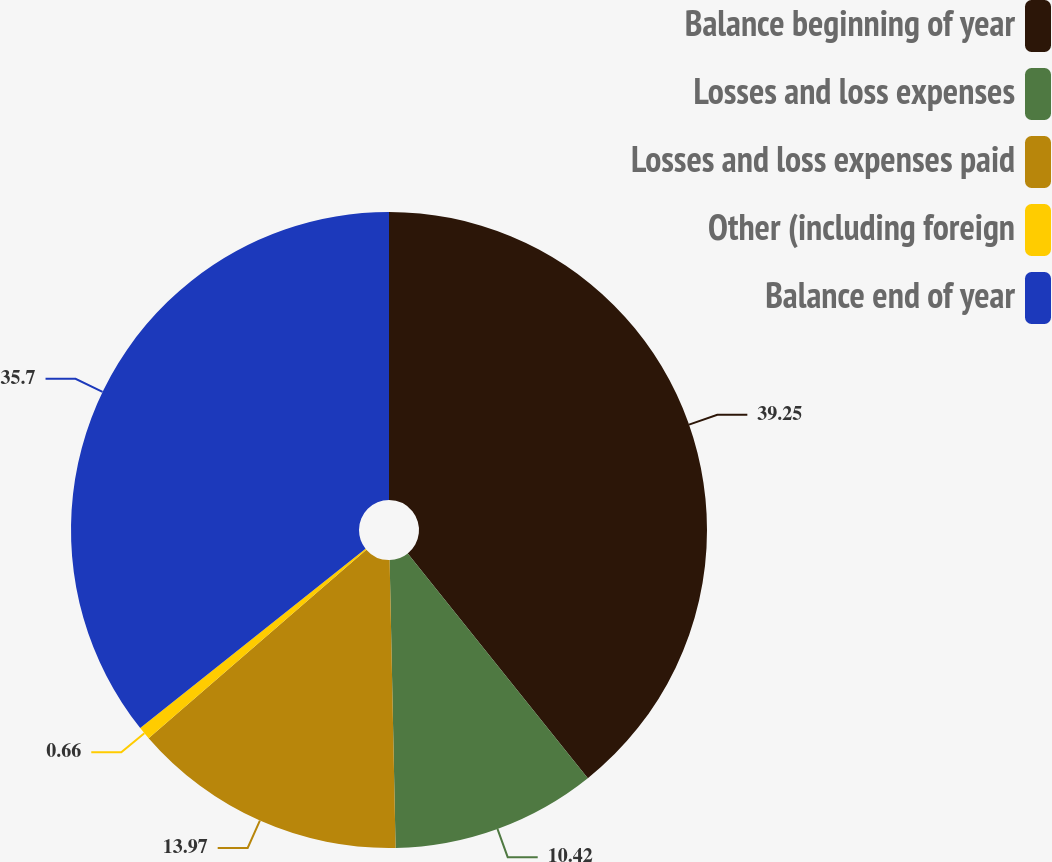<chart> <loc_0><loc_0><loc_500><loc_500><pie_chart><fcel>Balance beginning of year<fcel>Losses and loss expenses<fcel>Losses and loss expenses paid<fcel>Other (including foreign<fcel>Balance end of year<nl><fcel>39.25%<fcel>10.42%<fcel>13.97%<fcel>0.66%<fcel>35.7%<nl></chart> 